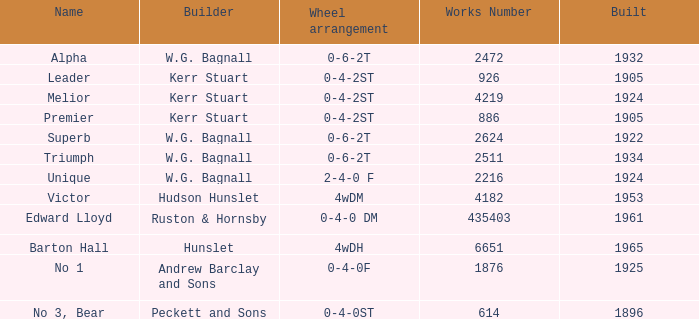What is the average building year for Superb? 1922.0. 